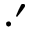<formula> <loc_0><loc_0><loc_500><loc_500>\cdot ^ { \prime }</formula> 